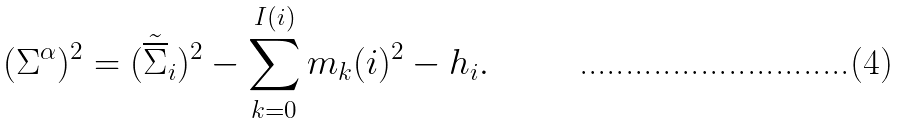Convert formula to latex. <formula><loc_0><loc_0><loc_500><loc_500>( \Sigma ^ { \alpha } ) ^ { 2 } = ( \tilde { \overline { \Sigma } } _ { i } ) ^ { 2 } - \sum _ { k = 0 } ^ { I ( i ) } m _ { k } ( i ) ^ { 2 } - h _ { i } .</formula> 